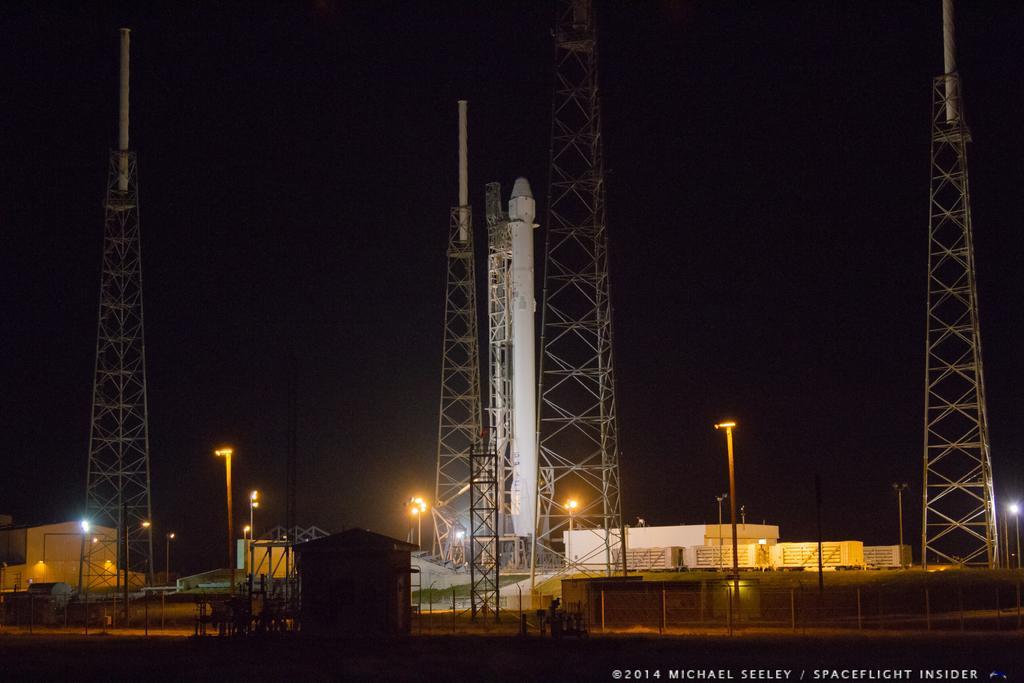In one or two sentences, can you explain what this image depicts? In this picture I can see fence, there are sheds, there are poles, lights, there are four towers near the rocket, and there is a watermark on the image. 